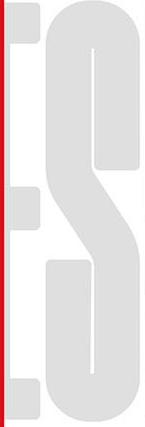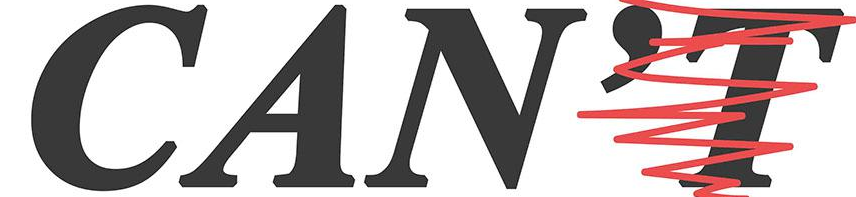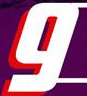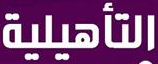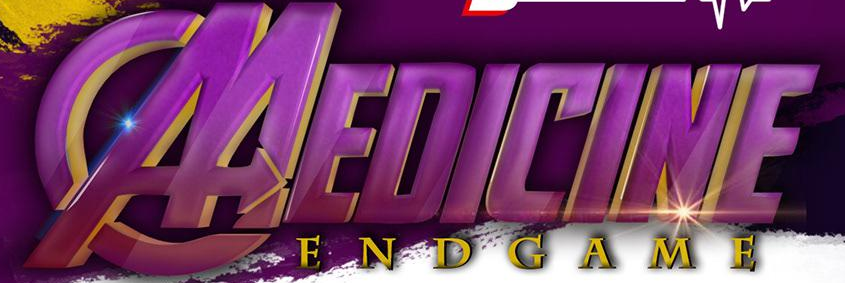Read the text from these images in sequence, separated by a semicolon. ES; CAN'T; g; ###; MEDICINE 